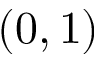<formula> <loc_0><loc_0><loc_500><loc_500>\left ( 0 , 1 \right )</formula> 